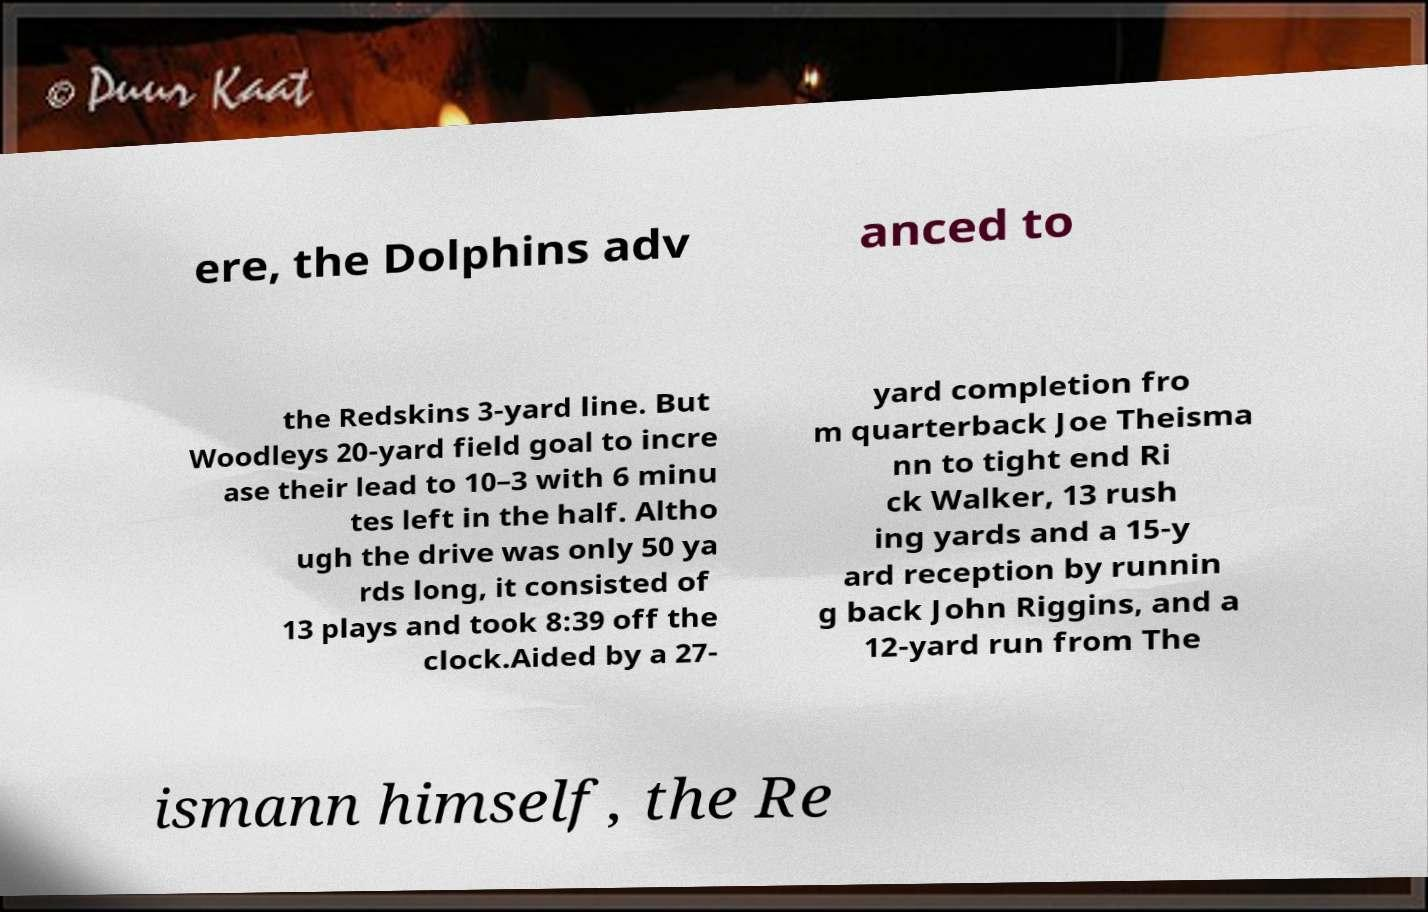Could you assist in decoding the text presented in this image and type it out clearly? ere, the Dolphins adv anced to the Redskins 3-yard line. But Woodleys 20-yard field goal to incre ase their lead to 10–3 with 6 minu tes left in the half. Altho ugh the drive was only 50 ya rds long, it consisted of 13 plays and took 8:39 off the clock.Aided by a 27- yard completion fro m quarterback Joe Theisma nn to tight end Ri ck Walker, 13 rush ing yards and a 15-y ard reception by runnin g back John Riggins, and a 12-yard run from The ismann himself, the Re 